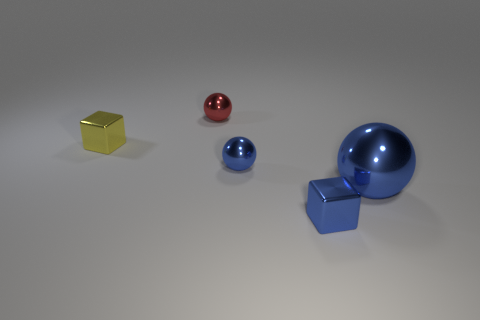There is a tiny object that is to the right of the small red shiny thing and behind the blue shiny block; what is its shape?
Provide a short and direct response. Sphere. Is the number of yellow things that are to the left of the yellow block the same as the number of yellow metal objects?
Offer a terse response. No. What number of things are either blue things or tiny red objects left of the tiny blue shiny block?
Make the answer very short. 4. Are there any other big metallic objects that have the same shape as the big blue metallic thing?
Make the answer very short. No. Is the number of tiny shiny blocks behind the red ball the same as the number of small yellow blocks that are left of the yellow block?
Provide a succinct answer. Yes. Is there any other thing that has the same size as the red object?
Ensure brevity in your answer.  Yes. What number of yellow things are tiny metallic balls or spheres?
Provide a succinct answer. 0. How many metal blocks have the same size as the red shiny thing?
Offer a terse response. 2. There is a sphere that is both to the right of the red sphere and behind the big ball; what color is it?
Make the answer very short. Blue. Are there more small yellow objects on the right side of the large blue metallic ball than tiny blue cubes?
Ensure brevity in your answer.  No. 